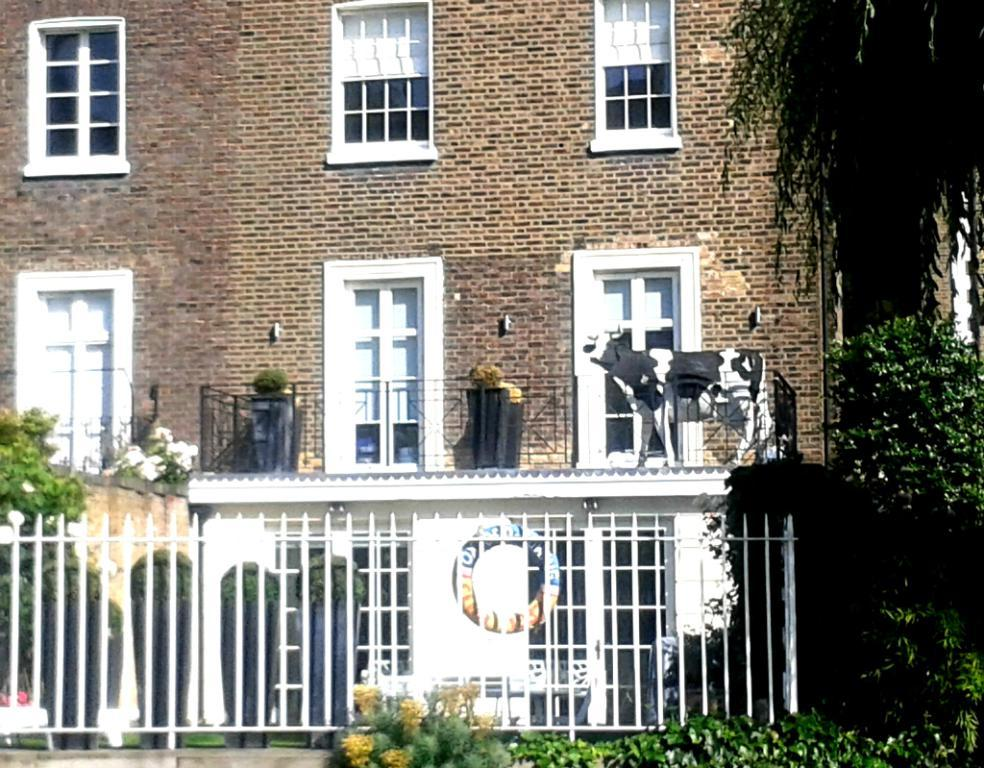What type of structure is present in the image? There is a building with windows in the image. What type of barrier can be seen in the image? There is a fence in the image. What object in the image is typically used for transporting substances? There is a tube in the image. What type of vegetation is present in the image? There are trees in the image. What type of plant is visible in the image? There is a plant in the image. What type of animal is present in the image? There is a cow in the image. How many bikes are parked near the building in the image? There are no bikes present in the image. What type of dish is the cow eating in the image? There is no dish or food present in the image, and the cow is not eating anything. 